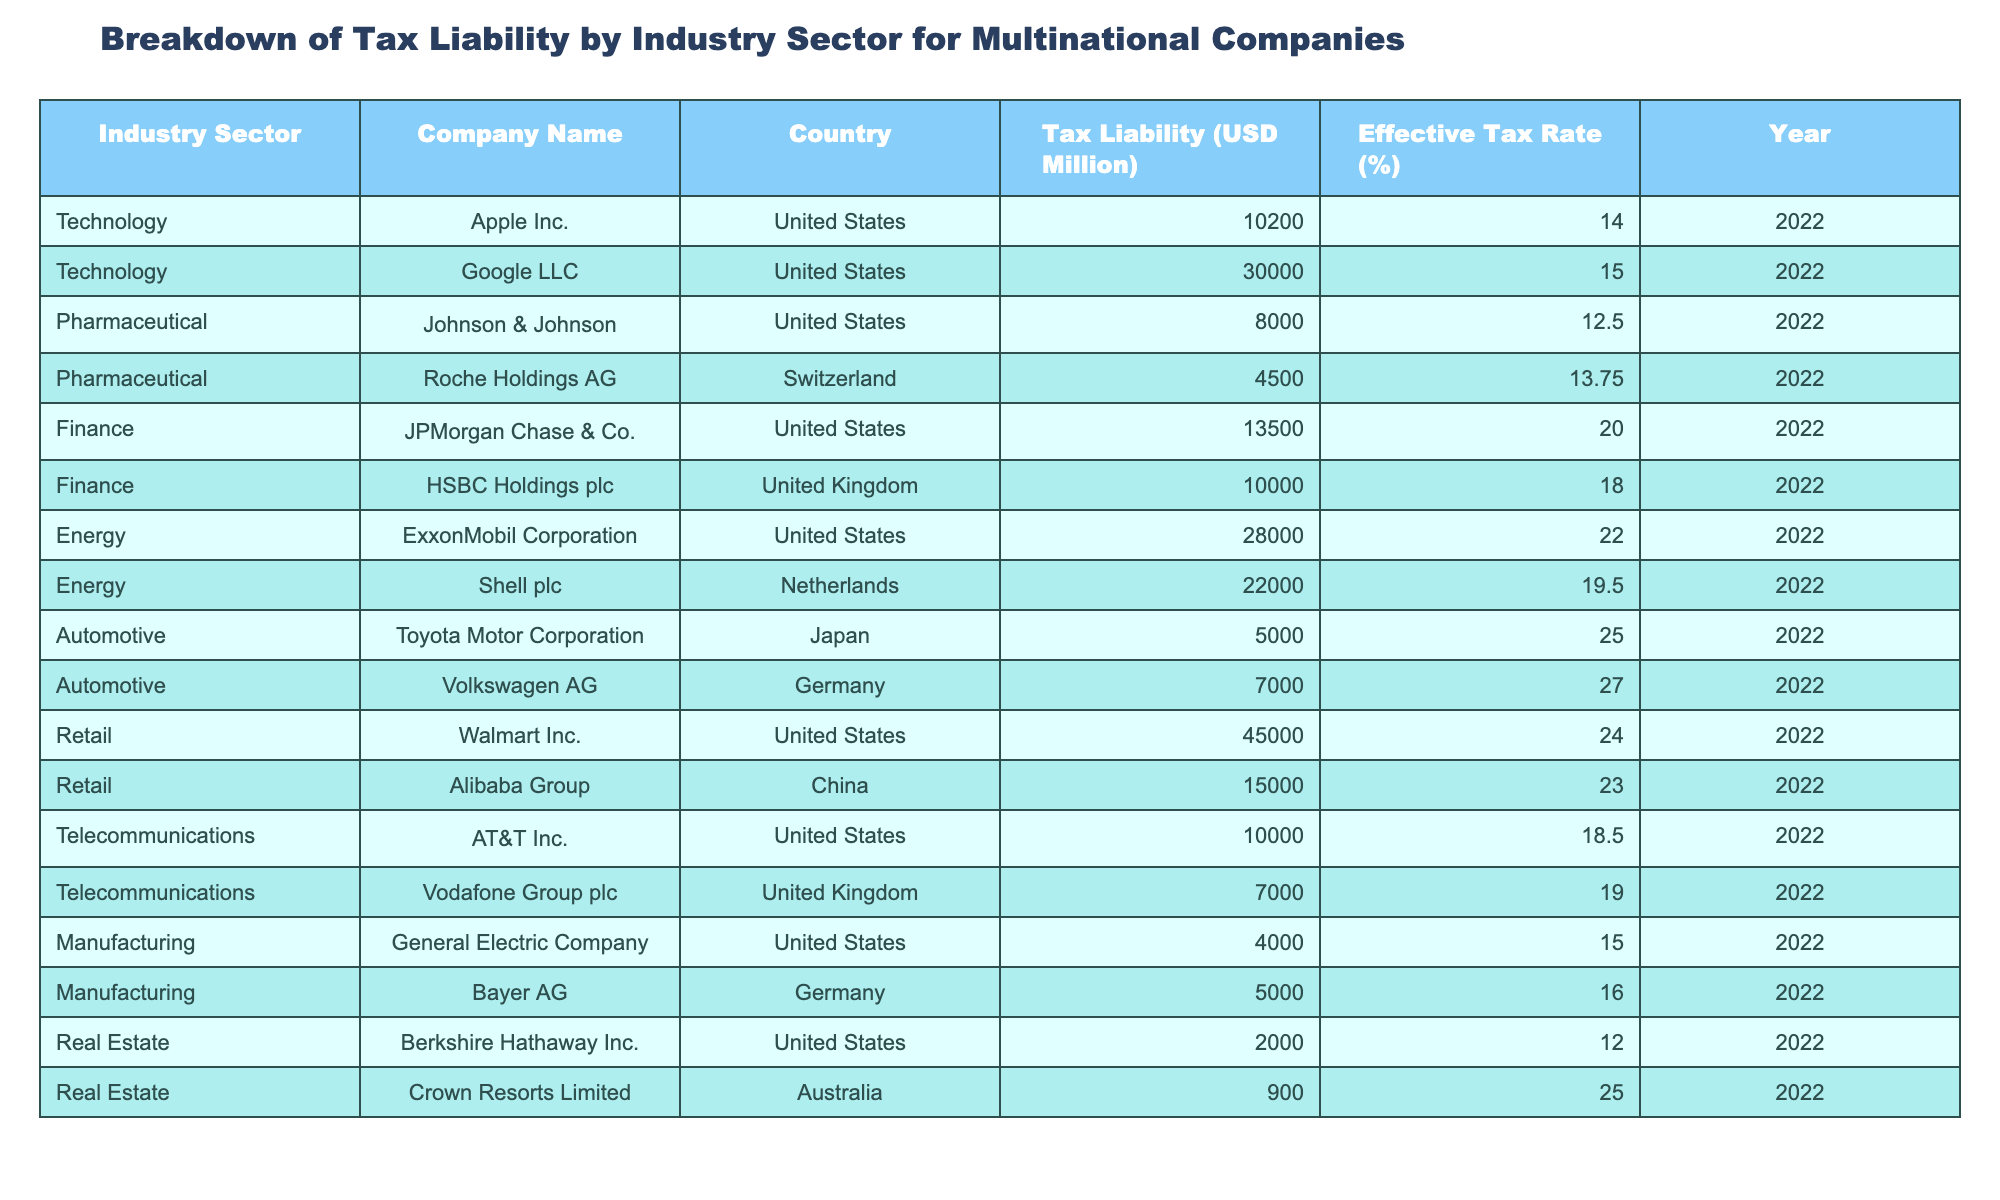What is the tax liability for Walmart Inc.? According to the table, Walmart Inc. has a tax liability listed as 45,000 million USD.
Answer: 45,000 million USD Which company has the highest effective tax rate? From the table, Toyota Motor Corporation has the highest effective tax rate at 25.00%.
Answer: 25.00% How much more tax liability does Google LLC have compared to Johnson & Johnson? Google LLC's tax liability is 30,000 million USD and Johnson & Johnson's is 8,000 million USD. The difference is 30,000 - 8,000 = 22,000 million USD.
Answer: 22,000 million USD Is the effective tax rate for ExxonMobil Corporation greater than the average effective tax rate of the automotive sector? ExxonMobil Corporation has an effective tax rate of 22.00%. The automotive sector has effective tax rates of 25.00% (Toyota) and 27.00% (Volkswagen), with an average of (25 + 27)/2 = 26.00%. Since 22.00% is less than 26.00%, the statement is false.
Answer: No What is the total tax liability for all companies in the pharmaceutical sector? The tax liabilities for the pharmaceutical sector, which are Johnson & Johnson at 8,000 million and Roche Holdings AG at 4,500 million, sum to 8,000 + 4,500 = 12,500 million USD.
Answer: 12,500 million USD Which industry sector has the lowest total tax liability? The real estate sector has the lowest tax liabilities: 2,000 million USD (Berkshire Hathaway) and 900 million USD (Crown Resorts), totaling 2,900 million USD. Comparing to others, this is the lowest total.
Answer: Real Estate What percentage of the total tax liability does the technology sector represent? The total tax liability from the technology sector is 10,200 million (Apple) + 30,000 million (Google) = 40,200 million USD. The total tax liability across all sectors is 220,000 million USD (calculated as the sum of all tax liabilities in the table). Therefore, the percentage is (40,200 / 220,000) * 100 ≈ 18.27%.
Answer: Approximately 18.27% Is the statement true that Alibaba Group's tax liability is less than that of JPMorgan Chase & Co.? Alibaba Group has a tax liability of 15,000 million USD, while JPMorgan Chase & Co. has a tax liability of 13,500 million USD. Since 15,000 is greater than 13,500, the statement is false.
Answer: No What is the average effective tax rate for the finance sector? The finance sector includes JPMorgan Chase & Co. at 20.00% and HSBC Holdings plc at 18.00%. The average is (20.00 + 18.00) / 2 = 19.00%.
Answer: 19.00% 